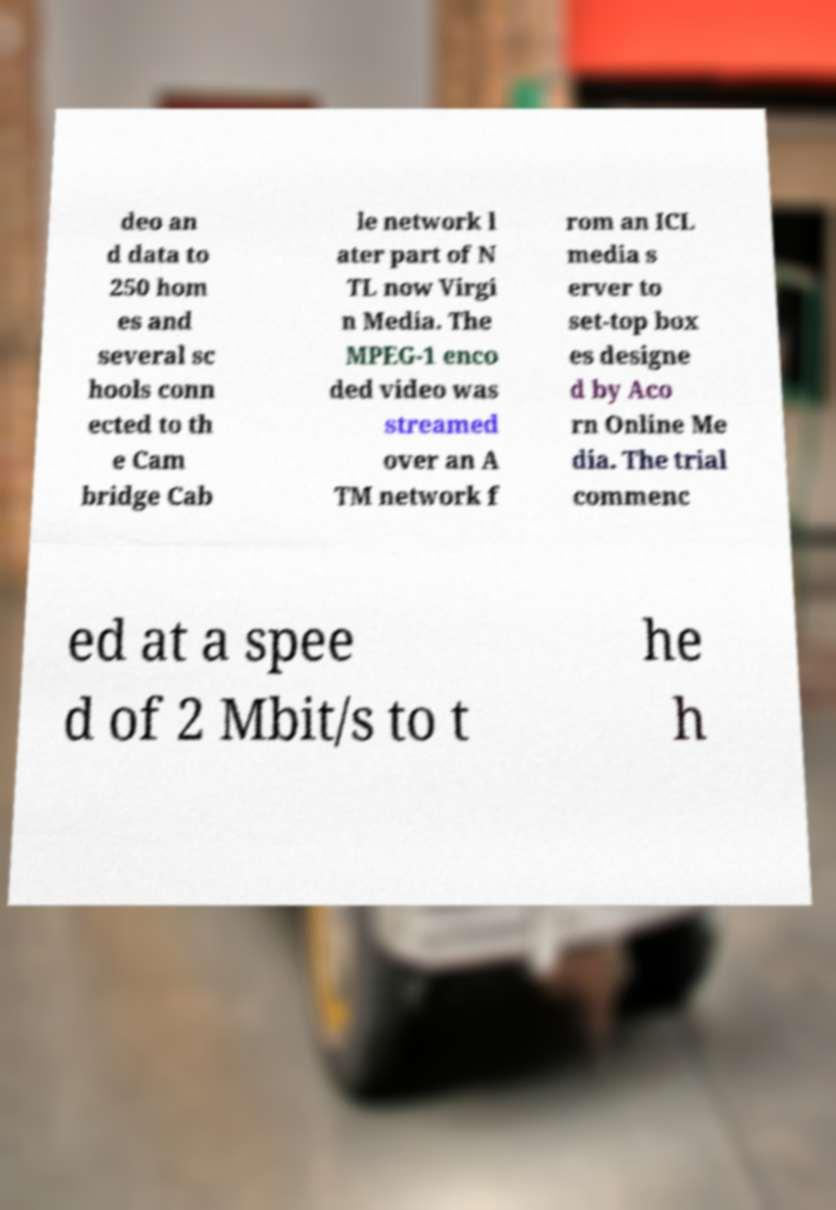Can you read and provide the text displayed in the image?This photo seems to have some interesting text. Can you extract and type it out for me? deo an d data to 250 hom es and several sc hools conn ected to th e Cam bridge Cab le network l ater part of N TL now Virgi n Media. The MPEG-1 enco ded video was streamed over an A TM network f rom an ICL media s erver to set-top box es designe d by Aco rn Online Me dia. The trial commenc ed at a spee d of 2 Mbit/s to t he h 